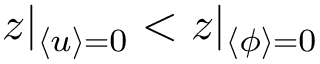Convert formula to latex. <formula><loc_0><loc_0><loc_500><loc_500>z | _ { \langle u \rangle = 0 } < z | _ { \langle \phi \rangle = 0 }</formula> 